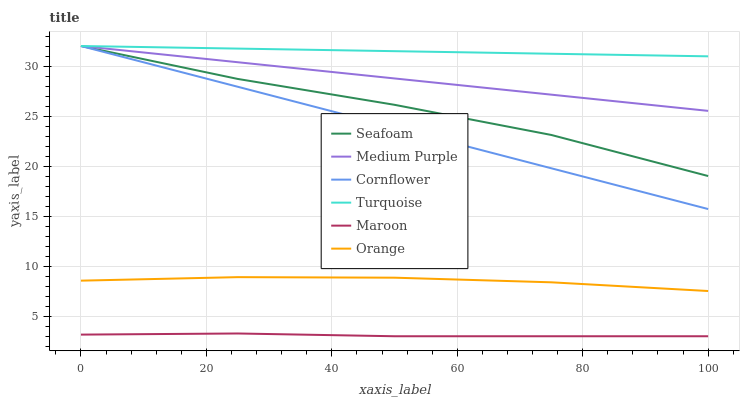Does Maroon have the minimum area under the curve?
Answer yes or no. Yes. Does Turquoise have the maximum area under the curve?
Answer yes or no. Yes. Does Seafoam have the minimum area under the curve?
Answer yes or no. No. Does Seafoam have the maximum area under the curve?
Answer yes or no. No. Is Cornflower the smoothest?
Answer yes or no. Yes. Is Seafoam the roughest?
Answer yes or no. Yes. Is Turquoise the smoothest?
Answer yes or no. No. Is Turquoise the roughest?
Answer yes or no. No. Does Seafoam have the lowest value?
Answer yes or no. No. Does Medium Purple have the highest value?
Answer yes or no. Yes. Does Maroon have the highest value?
Answer yes or no. No. Is Maroon less than Cornflower?
Answer yes or no. Yes. Is Turquoise greater than Maroon?
Answer yes or no. Yes. Does Maroon intersect Cornflower?
Answer yes or no. No. 